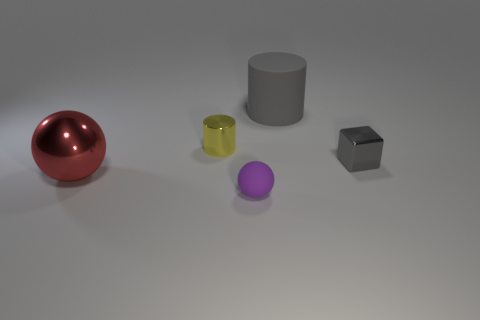Add 2 yellow rubber spheres. How many objects exist? 7 Subtract 1 cylinders. How many cylinders are left? 1 Subtract all purple balls. How many balls are left? 1 Subtract all cubes. How many objects are left? 4 Add 1 small rubber balls. How many small rubber balls exist? 2 Subtract 0 blue cubes. How many objects are left? 5 Subtract all cyan cylinders. Subtract all cyan balls. How many cylinders are left? 2 Subtract all gray things. Subtract all small gray objects. How many objects are left? 2 Add 5 metal blocks. How many metal blocks are left? 6 